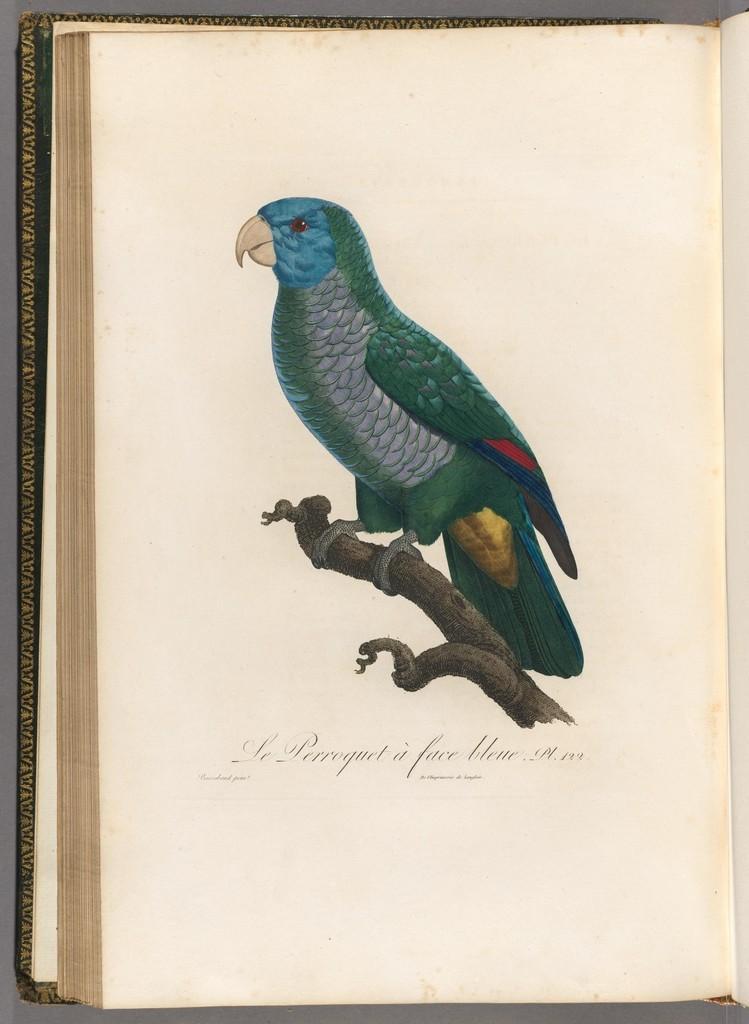In one or two sentences, can you explain what this image depicts? In this image I can see a book and there is a painting of a bird which is on a stem. At the bottom there is a text. 